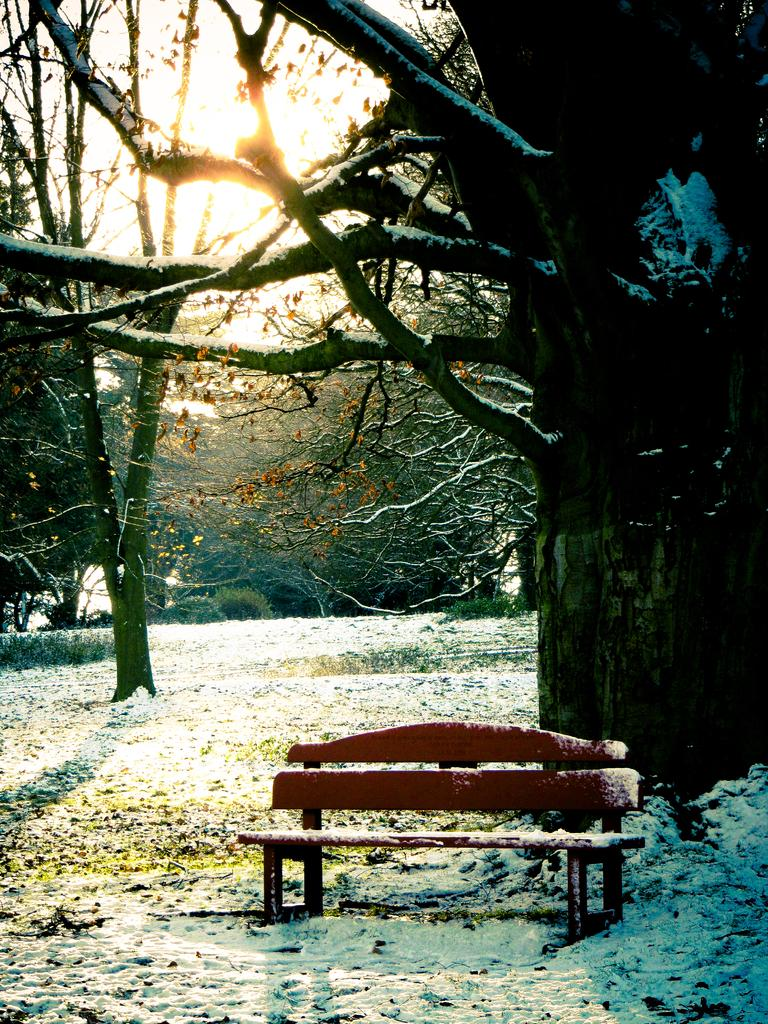What type of seating is visible in the image? There is a bench in the image. What is the ground covered with in the image? There is snow in the image, and shredded leaves are also present. What type of vegetation can be seen in the image? There are trees in the image. What is visible in the background of the image? The sky is visible in the image, and the sun is observable in the sky. What type of books can be seen stacked on the dock in the image? There is no dock or books present in the image. 